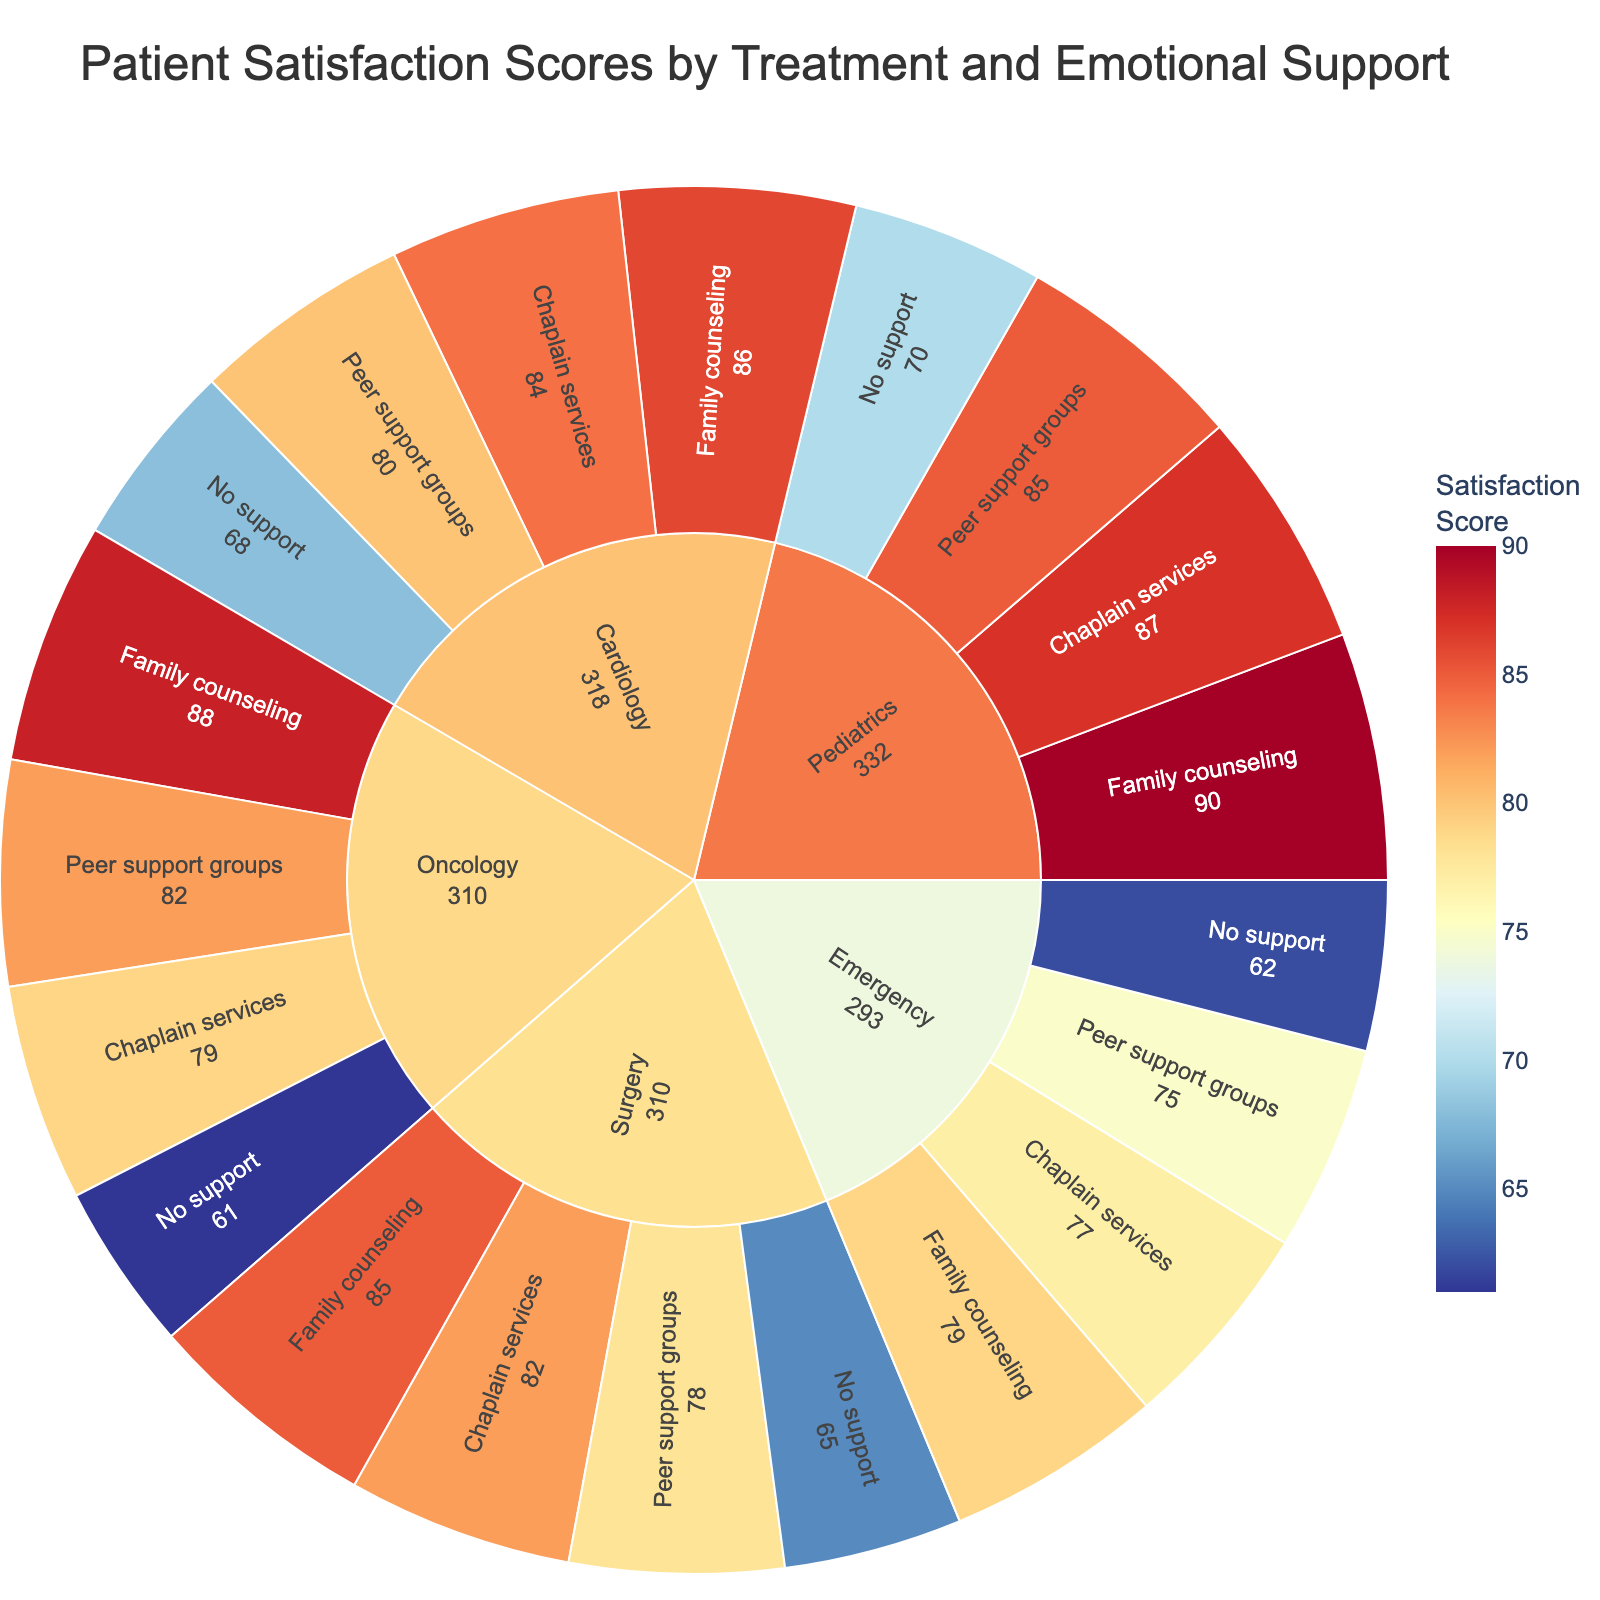What is the title of the figure? The title is formatted in larger font at the top of the figure.
Answer: Patient Satisfaction Scores by Treatment and Emotional Support What kind of emotional support is associated with the highest satisfaction score in Pediatrics? Find the segment under Pediatrics with the largest satisfaction value.
Answer: Family counseling Which treatment type has the lowest patient satisfaction score? Identify the segment with the smallest satisfaction value across all categories.
Answer: Oncology with No support Compare the satisfaction scores between Family counseling and No support under Surgery. Locate the segments under Surgery for both Family counseling and No support, then compare their scores. Family counseling has a score of 85, while No support has a score of 65.
Answer: Family counseling is higher What is the average satisfaction score for the treatments with Peer support groups? Identify all Peer support groups segments, sum their satisfaction scores, then divide by the number of those segments. (78+82+80+85+75)/5 = 80
Answer: 80 Which treatment type shows the greatest improvement in patient satisfaction by providing Family counseling compared to No support? For each treatment type, subtract the satisfaction score of No support from Family counseling and find the largest difference. Pediatrics: 90-70, Emergency: 79-62, Cardiology: 86-68, Oncology: 88-61, Surgery: 85-65. The largest difference is 27 in Oncology.
Answer: Oncology How many types of emotional supports are analyzed in the plot? Count the different segments under any treatment category.
Answer: Four Which emotional support type consistently provides better satisfaction scores across all treatment types? Compare the satisfaction scores for each emotional support type and check their overall consistency across treatment types. Family counseling averages the highest scores across all treatments.
Answer: Family counseling What is the median satisfaction score for Chaplain services across all treatment types? List the Chaplain services satisfaction scores (82, 79, 84, 87, 77), sort them (77, 79, 82, 84, 87) and find the middle value.
Answer: 82 